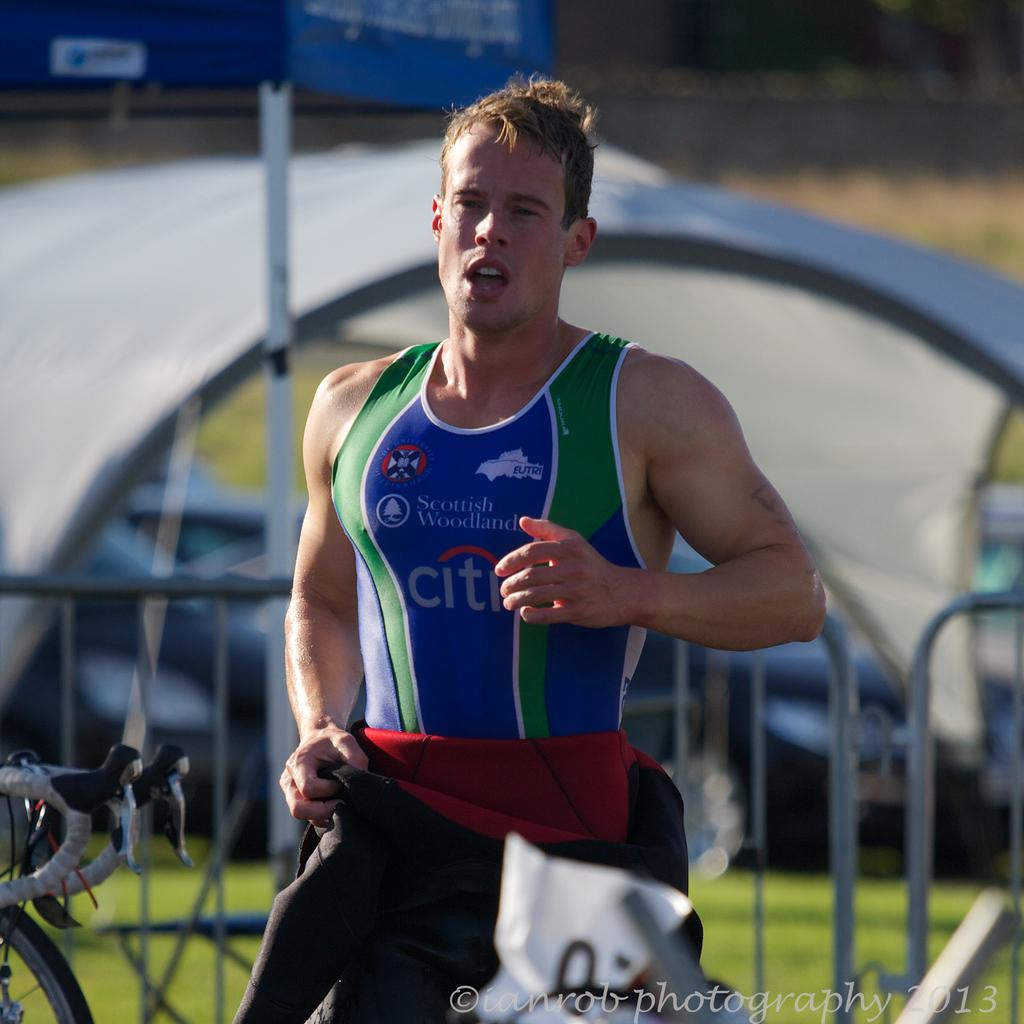<image>
Summarize the visual content of the image. A Scottish Wodland runner wearing tank sponsored by CITI 